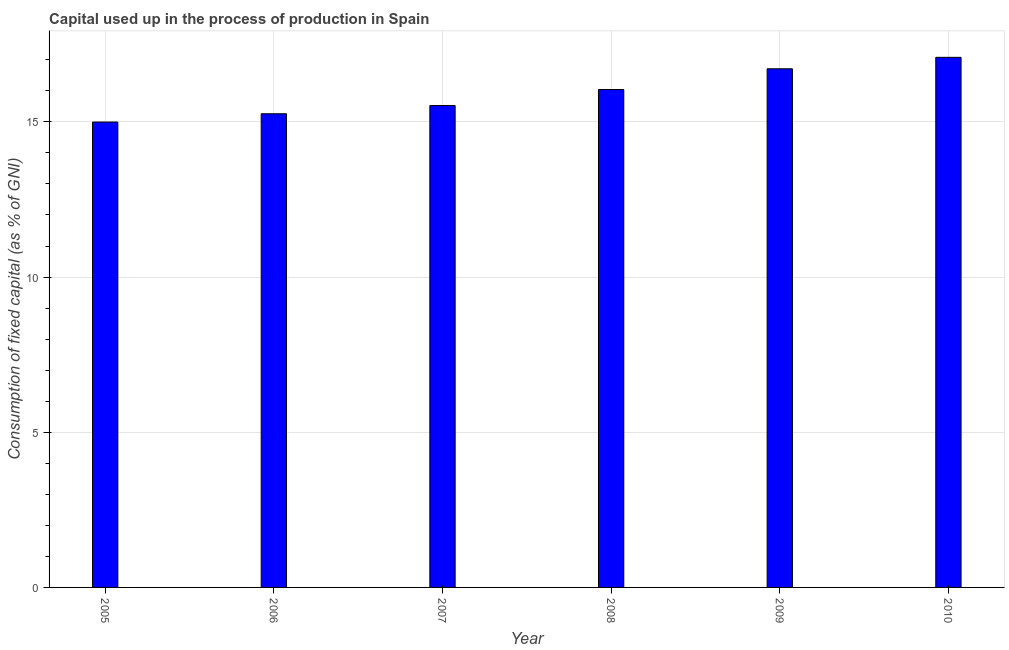What is the title of the graph?
Offer a terse response. Capital used up in the process of production in Spain. What is the label or title of the Y-axis?
Your answer should be compact. Consumption of fixed capital (as % of GNI). What is the consumption of fixed capital in 2007?
Provide a short and direct response. 15.53. Across all years, what is the maximum consumption of fixed capital?
Make the answer very short. 17.08. Across all years, what is the minimum consumption of fixed capital?
Provide a succinct answer. 14.99. In which year was the consumption of fixed capital maximum?
Offer a terse response. 2010. In which year was the consumption of fixed capital minimum?
Offer a very short reply. 2005. What is the sum of the consumption of fixed capital?
Ensure brevity in your answer.  95.61. What is the difference between the consumption of fixed capital in 2007 and 2009?
Offer a very short reply. -1.18. What is the average consumption of fixed capital per year?
Your answer should be compact. 15.94. What is the median consumption of fixed capital?
Your answer should be compact. 15.78. In how many years, is the consumption of fixed capital greater than 3 %?
Your answer should be compact. 6. What is the ratio of the consumption of fixed capital in 2005 to that in 2008?
Make the answer very short. 0.94. What is the difference between the highest and the second highest consumption of fixed capital?
Provide a succinct answer. 0.37. What is the difference between the highest and the lowest consumption of fixed capital?
Offer a terse response. 2.09. In how many years, is the consumption of fixed capital greater than the average consumption of fixed capital taken over all years?
Offer a very short reply. 3. How many bars are there?
Keep it short and to the point. 6. Are all the bars in the graph horizontal?
Provide a succinct answer. No. How many years are there in the graph?
Your answer should be compact. 6. What is the difference between two consecutive major ticks on the Y-axis?
Your answer should be very brief. 5. What is the Consumption of fixed capital (as % of GNI) of 2005?
Make the answer very short. 14.99. What is the Consumption of fixed capital (as % of GNI) of 2006?
Your answer should be compact. 15.26. What is the Consumption of fixed capital (as % of GNI) in 2007?
Offer a terse response. 15.53. What is the Consumption of fixed capital (as % of GNI) of 2008?
Offer a very short reply. 16.04. What is the Consumption of fixed capital (as % of GNI) in 2009?
Provide a succinct answer. 16.71. What is the Consumption of fixed capital (as % of GNI) in 2010?
Ensure brevity in your answer.  17.08. What is the difference between the Consumption of fixed capital (as % of GNI) in 2005 and 2006?
Offer a very short reply. -0.27. What is the difference between the Consumption of fixed capital (as % of GNI) in 2005 and 2007?
Your response must be concise. -0.53. What is the difference between the Consumption of fixed capital (as % of GNI) in 2005 and 2008?
Offer a terse response. -1.05. What is the difference between the Consumption of fixed capital (as % of GNI) in 2005 and 2009?
Your response must be concise. -1.72. What is the difference between the Consumption of fixed capital (as % of GNI) in 2005 and 2010?
Your answer should be very brief. -2.09. What is the difference between the Consumption of fixed capital (as % of GNI) in 2006 and 2007?
Your answer should be very brief. -0.27. What is the difference between the Consumption of fixed capital (as % of GNI) in 2006 and 2008?
Ensure brevity in your answer.  -0.78. What is the difference between the Consumption of fixed capital (as % of GNI) in 2006 and 2009?
Offer a terse response. -1.45. What is the difference between the Consumption of fixed capital (as % of GNI) in 2006 and 2010?
Your answer should be compact. -1.82. What is the difference between the Consumption of fixed capital (as % of GNI) in 2007 and 2008?
Offer a terse response. -0.51. What is the difference between the Consumption of fixed capital (as % of GNI) in 2007 and 2009?
Provide a short and direct response. -1.18. What is the difference between the Consumption of fixed capital (as % of GNI) in 2007 and 2010?
Ensure brevity in your answer.  -1.55. What is the difference between the Consumption of fixed capital (as % of GNI) in 2008 and 2009?
Offer a terse response. -0.67. What is the difference between the Consumption of fixed capital (as % of GNI) in 2008 and 2010?
Offer a very short reply. -1.04. What is the difference between the Consumption of fixed capital (as % of GNI) in 2009 and 2010?
Your answer should be compact. -0.37. What is the ratio of the Consumption of fixed capital (as % of GNI) in 2005 to that in 2006?
Provide a short and direct response. 0.98. What is the ratio of the Consumption of fixed capital (as % of GNI) in 2005 to that in 2008?
Your answer should be compact. 0.94. What is the ratio of the Consumption of fixed capital (as % of GNI) in 2005 to that in 2009?
Give a very brief answer. 0.9. What is the ratio of the Consumption of fixed capital (as % of GNI) in 2005 to that in 2010?
Give a very brief answer. 0.88. What is the ratio of the Consumption of fixed capital (as % of GNI) in 2006 to that in 2007?
Keep it short and to the point. 0.98. What is the ratio of the Consumption of fixed capital (as % of GNI) in 2006 to that in 2008?
Give a very brief answer. 0.95. What is the ratio of the Consumption of fixed capital (as % of GNI) in 2006 to that in 2009?
Offer a very short reply. 0.91. What is the ratio of the Consumption of fixed capital (as % of GNI) in 2006 to that in 2010?
Offer a very short reply. 0.89. What is the ratio of the Consumption of fixed capital (as % of GNI) in 2007 to that in 2008?
Your answer should be very brief. 0.97. What is the ratio of the Consumption of fixed capital (as % of GNI) in 2007 to that in 2009?
Provide a short and direct response. 0.93. What is the ratio of the Consumption of fixed capital (as % of GNI) in 2007 to that in 2010?
Keep it short and to the point. 0.91. What is the ratio of the Consumption of fixed capital (as % of GNI) in 2008 to that in 2010?
Give a very brief answer. 0.94. 